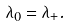<formula> <loc_0><loc_0><loc_500><loc_500>\lambda _ { 0 } = \lambda _ { + } .</formula> 